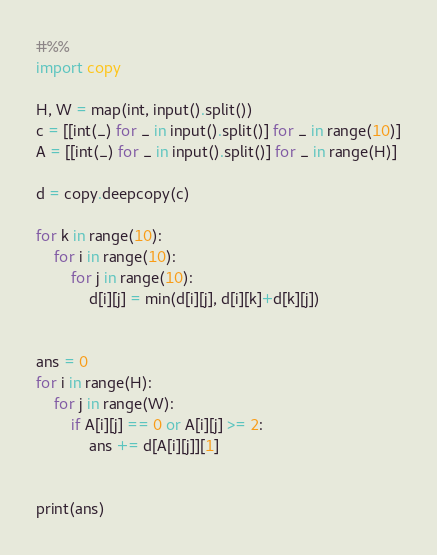<code> <loc_0><loc_0><loc_500><loc_500><_Python_>#%%
import copy 

H, W = map(int, input().split())
c = [[int(_) for _ in input().split()] for _ in range(10)]
A = [[int(_) for _ in input().split()] for _ in range(H)]

d = copy.deepcopy(c)

for k in range(10):
    for i in range(10):
        for j in range(10):
            d[i][j] = min(d[i][j], d[i][k]+d[k][j])


ans = 0
for i in range(H):
    for j in range(W):
        if A[i][j] == 0 or A[i][j] >= 2:
            ans += d[A[i][j]][1]


print(ans)</code> 